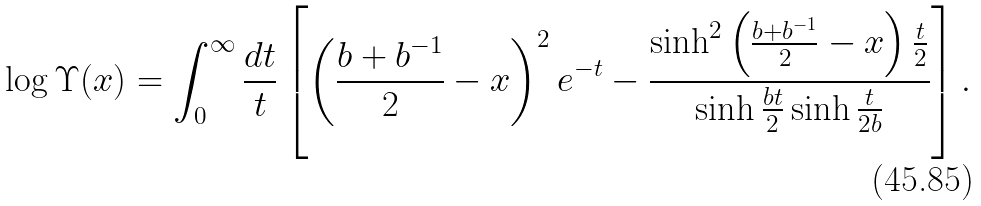<formula> <loc_0><loc_0><loc_500><loc_500>\log \Upsilon ( x ) = \int _ { 0 } ^ { \infty } \frac { d t } { t } \left [ \left ( \frac { b + b ^ { - 1 } } { 2 } - x \right ) ^ { 2 } e ^ { - t } - \frac { \sinh ^ { 2 } \left ( \frac { b + b ^ { - 1 } } { 2 } - x \right ) \frac { t } { 2 } } { \sinh \frac { b t } { 2 } \sinh \frac { t } { 2 b } } \right ] .</formula> 